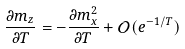<formula> <loc_0><loc_0><loc_500><loc_500>\frac { \partial m _ { z } } { \partial T } = - \frac { \partial m _ { x } ^ { 2 } } { \partial T } + \mathcal { O } ( e ^ { - 1 / T } )</formula> 